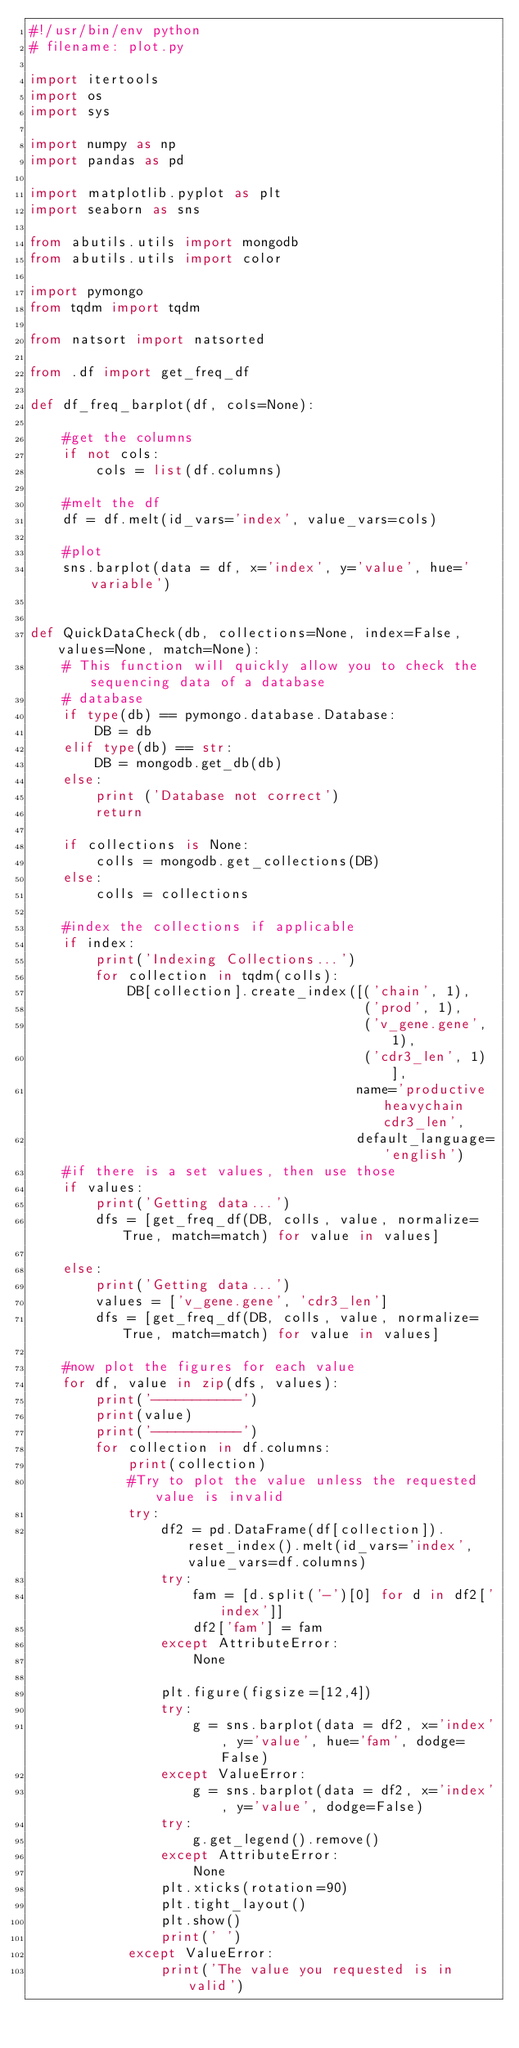<code> <loc_0><loc_0><loc_500><loc_500><_Python_>#!/usr/bin/env python
# filename: plot.py

import itertools
import os
import sys

import numpy as np
import pandas as pd

import matplotlib.pyplot as plt
import seaborn as sns

from abutils.utils import mongodb
from abutils.utils import color

import pymongo
from tqdm import tqdm

from natsort import natsorted

from .df import get_freq_df

def df_freq_barplot(df, cols=None):

    #get the columns
    if not cols:
        cols = list(df.columns)

    #melt the df
    df = df.melt(id_vars='index', value_vars=cols)

    #plot
    sns.barplot(data = df, x='index', y='value', hue='variable')
    
    
def QuickDataCheck(db, collections=None, index=False, values=None, match=None):
    # This function will quickly allow you to check the sequencing data of a database
    # database
    if type(db) == pymongo.database.Database:
        DB = db
    elif type(db) == str:
        DB = mongodb.get_db(db)
    else:
        print ('Database not correct')
        return
    
    if collections is None:
        colls = mongodb.get_collections(DB)
    else:
        colls = collections
    
    #index the collections if applicable 
    if index:
        print('Indexing Collections...')
        for collection in tqdm(colls):
            DB[collection].create_index([('chain', 1),
                                         ('prod', 1), 
                                         ('v_gene.gene', 1), 
                                         ('cdr3_len', 1)], 
                                        name='productive heavychain cdr3_len', 
                                        default_language='english')
    #if there is a set values, then use those
    if values:
        print('Getting data...')
        dfs = [get_freq_df(DB, colls, value, normalize=True, match=match) for value in values]

    else:
        print('Getting data...')
        values = ['v_gene.gene', 'cdr3_len']
        dfs = [get_freq_df(DB, colls, value, normalize=True, match=match) for value in values]
    
    #now plot the figures for each value
    for df, value in zip(dfs, values):
        print('-----------')
        print(value)
        print('-----------')
        for collection in df.columns:
            print(collection)
            #Try to plot the value unless the requested value is invalid
            try:
                df2 = pd.DataFrame(df[collection]).reset_index().melt(id_vars='index', value_vars=df.columns)
                try:
                    fam = [d.split('-')[0] for d in df2['index']]
                    df2['fam'] = fam
                except AttributeError:
                    None

                plt.figure(figsize=[12,4])
                try:
                    g = sns.barplot(data = df2, x='index', y='value', hue='fam', dodge=False) 
                except ValueError:
                    g = sns.barplot(data = df2, x='index', y='value', dodge=False)
                try:
                    g.get_legend().remove()
                except AttributeError:
                    None
                plt.xticks(rotation=90)
                plt.tight_layout()
                plt.show()
                print(' ')
            except ValueError:
                print('The value you requested is in valid')

</code> 